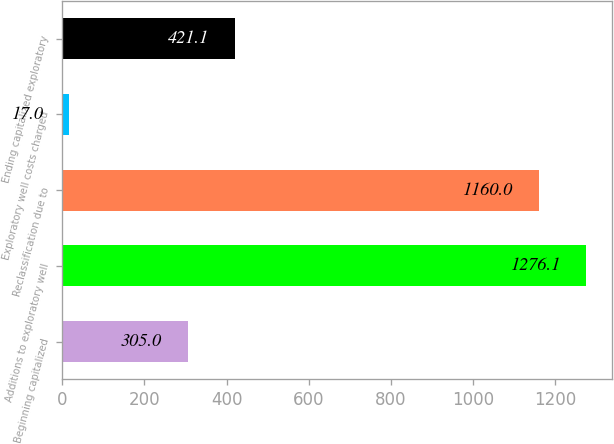<chart> <loc_0><loc_0><loc_500><loc_500><bar_chart><fcel>Beginning capitalized<fcel>Additions to exploratory well<fcel>Reclassification due to<fcel>Exploratory well costs charged<fcel>Ending capitalized exploratory<nl><fcel>305<fcel>1276.1<fcel>1160<fcel>17<fcel>421.1<nl></chart> 